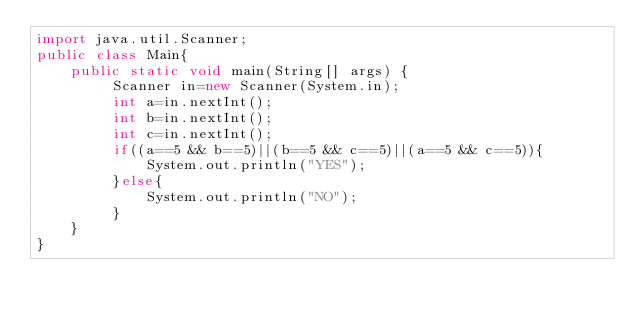Convert code to text. <code><loc_0><loc_0><loc_500><loc_500><_Java_>import java.util.Scanner;
public class Main{
    public static void main(String[] args) {
         Scanner in=new Scanner(System.in);
         int a=in.nextInt();
         int b=in.nextInt();
         int c=in.nextInt();
         if((a==5 && b==5)||(b==5 && c==5)||(a==5 && c==5)){
             System.out.println("YES");
         }else{
             System.out.println("NO");
         }
    }
}</code> 